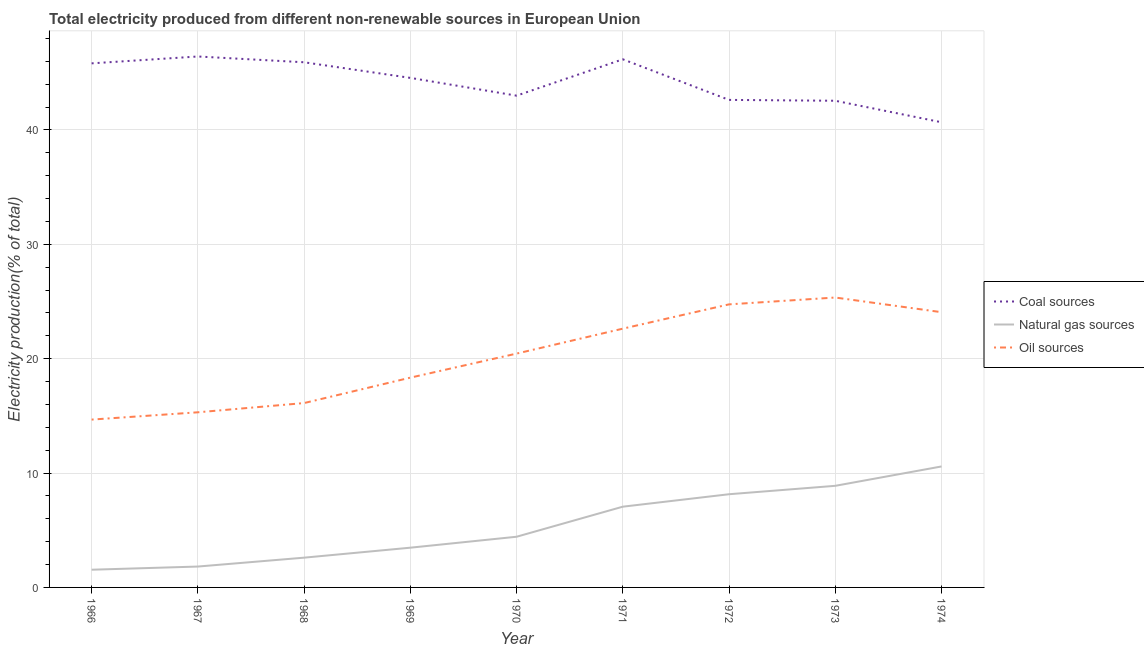What is the percentage of electricity produced by natural gas in 1974?
Offer a very short reply. 10.58. Across all years, what is the maximum percentage of electricity produced by natural gas?
Provide a succinct answer. 10.58. Across all years, what is the minimum percentage of electricity produced by coal?
Give a very brief answer. 40.67. In which year was the percentage of electricity produced by coal maximum?
Give a very brief answer. 1967. In which year was the percentage of electricity produced by natural gas minimum?
Your answer should be compact. 1966. What is the total percentage of electricity produced by coal in the graph?
Offer a terse response. 397.69. What is the difference between the percentage of electricity produced by coal in 1966 and that in 1969?
Offer a terse response. 1.27. What is the difference between the percentage of electricity produced by natural gas in 1974 and the percentage of electricity produced by coal in 1970?
Your answer should be compact. -32.42. What is the average percentage of electricity produced by coal per year?
Provide a succinct answer. 44.19. In the year 1972, what is the difference between the percentage of electricity produced by oil sources and percentage of electricity produced by coal?
Offer a very short reply. -17.87. What is the ratio of the percentage of electricity produced by coal in 1970 to that in 1974?
Give a very brief answer. 1.06. Is the percentage of electricity produced by oil sources in 1967 less than that in 1974?
Your response must be concise. Yes. Is the difference between the percentage of electricity produced by oil sources in 1967 and 1972 greater than the difference between the percentage of electricity produced by coal in 1967 and 1972?
Provide a short and direct response. No. What is the difference between the highest and the second highest percentage of electricity produced by oil sources?
Make the answer very short. 0.6. What is the difference between the highest and the lowest percentage of electricity produced by oil sources?
Provide a short and direct response. 10.67. In how many years, is the percentage of electricity produced by coal greater than the average percentage of electricity produced by coal taken over all years?
Your answer should be compact. 5. Is the sum of the percentage of electricity produced by oil sources in 1972 and 1974 greater than the maximum percentage of electricity produced by coal across all years?
Your answer should be very brief. Yes. Is the percentage of electricity produced by coal strictly greater than the percentage of electricity produced by natural gas over the years?
Offer a very short reply. Yes. What is the difference between two consecutive major ticks on the Y-axis?
Offer a terse response. 10. Are the values on the major ticks of Y-axis written in scientific E-notation?
Give a very brief answer. No. How many legend labels are there?
Keep it short and to the point. 3. How are the legend labels stacked?
Provide a short and direct response. Vertical. What is the title of the graph?
Offer a very short reply. Total electricity produced from different non-renewable sources in European Union. Does "Ages 0-14" appear as one of the legend labels in the graph?
Make the answer very short. No. What is the label or title of the Y-axis?
Give a very brief answer. Electricity production(% of total). What is the Electricity production(% of total) in Coal sources in 1966?
Your answer should be compact. 45.82. What is the Electricity production(% of total) in Natural gas sources in 1966?
Provide a short and direct response. 1.55. What is the Electricity production(% of total) of Oil sources in 1966?
Offer a terse response. 14.67. What is the Electricity production(% of total) in Coal sources in 1967?
Your answer should be very brief. 46.42. What is the Electricity production(% of total) of Natural gas sources in 1967?
Provide a succinct answer. 1.83. What is the Electricity production(% of total) of Oil sources in 1967?
Offer a very short reply. 15.31. What is the Electricity production(% of total) in Coal sources in 1968?
Make the answer very short. 45.91. What is the Electricity production(% of total) of Natural gas sources in 1968?
Your response must be concise. 2.6. What is the Electricity production(% of total) in Oil sources in 1968?
Ensure brevity in your answer.  16.12. What is the Electricity production(% of total) of Coal sources in 1969?
Provide a short and direct response. 44.55. What is the Electricity production(% of total) of Natural gas sources in 1969?
Give a very brief answer. 3.47. What is the Electricity production(% of total) of Oil sources in 1969?
Provide a succinct answer. 18.34. What is the Electricity production(% of total) in Coal sources in 1970?
Your answer should be very brief. 42.99. What is the Electricity production(% of total) in Natural gas sources in 1970?
Offer a very short reply. 4.43. What is the Electricity production(% of total) in Oil sources in 1970?
Your response must be concise. 20.44. What is the Electricity production(% of total) in Coal sources in 1971?
Ensure brevity in your answer.  46.17. What is the Electricity production(% of total) of Natural gas sources in 1971?
Your answer should be very brief. 7.06. What is the Electricity production(% of total) in Oil sources in 1971?
Your answer should be very brief. 22.62. What is the Electricity production(% of total) of Coal sources in 1972?
Give a very brief answer. 42.62. What is the Electricity production(% of total) in Natural gas sources in 1972?
Provide a succinct answer. 8.15. What is the Electricity production(% of total) of Oil sources in 1972?
Offer a terse response. 24.75. What is the Electricity production(% of total) of Coal sources in 1973?
Your answer should be compact. 42.55. What is the Electricity production(% of total) in Natural gas sources in 1973?
Provide a short and direct response. 8.88. What is the Electricity production(% of total) in Oil sources in 1973?
Provide a short and direct response. 25.34. What is the Electricity production(% of total) of Coal sources in 1974?
Your response must be concise. 40.67. What is the Electricity production(% of total) in Natural gas sources in 1974?
Offer a very short reply. 10.58. What is the Electricity production(% of total) of Oil sources in 1974?
Provide a short and direct response. 24.06. Across all years, what is the maximum Electricity production(% of total) in Coal sources?
Offer a terse response. 46.42. Across all years, what is the maximum Electricity production(% of total) of Natural gas sources?
Give a very brief answer. 10.58. Across all years, what is the maximum Electricity production(% of total) in Oil sources?
Your response must be concise. 25.34. Across all years, what is the minimum Electricity production(% of total) of Coal sources?
Provide a succinct answer. 40.67. Across all years, what is the minimum Electricity production(% of total) in Natural gas sources?
Keep it short and to the point. 1.55. Across all years, what is the minimum Electricity production(% of total) of Oil sources?
Offer a very short reply. 14.67. What is the total Electricity production(% of total) in Coal sources in the graph?
Offer a very short reply. 397.69. What is the total Electricity production(% of total) of Natural gas sources in the graph?
Provide a short and direct response. 48.55. What is the total Electricity production(% of total) in Oil sources in the graph?
Give a very brief answer. 181.66. What is the difference between the Electricity production(% of total) of Coal sources in 1966 and that in 1967?
Ensure brevity in your answer.  -0.6. What is the difference between the Electricity production(% of total) of Natural gas sources in 1966 and that in 1967?
Ensure brevity in your answer.  -0.28. What is the difference between the Electricity production(% of total) of Oil sources in 1966 and that in 1967?
Your answer should be very brief. -0.64. What is the difference between the Electricity production(% of total) in Coal sources in 1966 and that in 1968?
Provide a succinct answer. -0.09. What is the difference between the Electricity production(% of total) in Natural gas sources in 1966 and that in 1968?
Give a very brief answer. -1.05. What is the difference between the Electricity production(% of total) in Oil sources in 1966 and that in 1968?
Give a very brief answer. -1.44. What is the difference between the Electricity production(% of total) of Coal sources in 1966 and that in 1969?
Your answer should be very brief. 1.27. What is the difference between the Electricity production(% of total) in Natural gas sources in 1966 and that in 1969?
Your answer should be very brief. -1.93. What is the difference between the Electricity production(% of total) in Oil sources in 1966 and that in 1969?
Make the answer very short. -3.67. What is the difference between the Electricity production(% of total) in Coal sources in 1966 and that in 1970?
Your answer should be very brief. 2.82. What is the difference between the Electricity production(% of total) of Natural gas sources in 1966 and that in 1970?
Keep it short and to the point. -2.88. What is the difference between the Electricity production(% of total) in Oil sources in 1966 and that in 1970?
Offer a very short reply. -5.77. What is the difference between the Electricity production(% of total) of Coal sources in 1966 and that in 1971?
Provide a succinct answer. -0.35. What is the difference between the Electricity production(% of total) of Natural gas sources in 1966 and that in 1971?
Offer a very short reply. -5.51. What is the difference between the Electricity production(% of total) of Oil sources in 1966 and that in 1971?
Offer a terse response. -7.95. What is the difference between the Electricity production(% of total) of Coal sources in 1966 and that in 1972?
Ensure brevity in your answer.  3.2. What is the difference between the Electricity production(% of total) of Natural gas sources in 1966 and that in 1972?
Offer a terse response. -6.6. What is the difference between the Electricity production(% of total) of Oil sources in 1966 and that in 1972?
Provide a short and direct response. -10.07. What is the difference between the Electricity production(% of total) of Coal sources in 1966 and that in 1973?
Your answer should be very brief. 3.27. What is the difference between the Electricity production(% of total) of Natural gas sources in 1966 and that in 1973?
Make the answer very short. -7.33. What is the difference between the Electricity production(% of total) of Oil sources in 1966 and that in 1973?
Provide a succinct answer. -10.67. What is the difference between the Electricity production(% of total) of Coal sources in 1966 and that in 1974?
Ensure brevity in your answer.  5.15. What is the difference between the Electricity production(% of total) in Natural gas sources in 1966 and that in 1974?
Make the answer very short. -9.03. What is the difference between the Electricity production(% of total) in Oil sources in 1966 and that in 1974?
Your response must be concise. -9.39. What is the difference between the Electricity production(% of total) of Coal sources in 1967 and that in 1968?
Offer a very short reply. 0.51. What is the difference between the Electricity production(% of total) in Natural gas sources in 1967 and that in 1968?
Your response must be concise. -0.78. What is the difference between the Electricity production(% of total) in Oil sources in 1967 and that in 1968?
Provide a short and direct response. -0.81. What is the difference between the Electricity production(% of total) in Coal sources in 1967 and that in 1969?
Make the answer very short. 1.87. What is the difference between the Electricity production(% of total) of Natural gas sources in 1967 and that in 1969?
Your answer should be very brief. -1.65. What is the difference between the Electricity production(% of total) in Oil sources in 1967 and that in 1969?
Offer a terse response. -3.03. What is the difference between the Electricity production(% of total) in Coal sources in 1967 and that in 1970?
Provide a short and direct response. 3.42. What is the difference between the Electricity production(% of total) of Natural gas sources in 1967 and that in 1970?
Your answer should be compact. -2.61. What is the difference between the Electricity production(% of total) in Oil sources in 1967 and that in 1970?
Offer a very short reply. -5.13. What is the difference between the Electricity production(% of total) in Coal sources in 1967 and that in 1971?
Your answer should be very brief. 0.25. What is the difference between the Electricity production(% of total) of Natural gas sources in 1967 and that in 1971?
Your answer should be compact. -5.23. What is the difference between the Electricity production(% of total) in Oil sources in 1967 and that in 1971?
Keep it short and to the point. -7.31. What is the difference between the Electricity production(% of total) of Coal sources in 1967 and that in 1972?
Give a very brief answer. 3.8. What is the difference between the Electricity production(% of total) of Natural gas sources in 1967 and that in 1972?
Your response must be concise. -6.32. What is the difference between the Electricity production(% of total) of Oil sources in 1967 and that in 1972?
Keep it short and to the point. -9.44. What is the difference between the Electricity production(% of total) of Coal sources in 1967 and that in 1973?
Your answer should be very brief. 3.87. What is the difference between the Electricity production(% of total) of Natural gas sources in 1967 and that in 1973?
Ensure brevity in your answer.  -7.06. What is the difference between the Electricity production(% of total) in Oil sources in 1967 and that in 1973?
Your answer should be compact. -10.03. What is the difference between the Electricity production(% of total) of Coal sources in 1967 and that in 1974?
Give a very brief answer. 5.75. What is the difference between the Electricity production(% of total) of Natural gas sources in 1967 and that in 1974?
Keep it short and to the point. -8.75. What is the difference between the Electricity production(% of total) in Oil sources in 1967 and that in 1974?
Provide a succinct answer. -8.75. What is the difference between the Electricity production(% of total) in Coal sources in 1968 and that in 1969?
Make the answer very short. 1.36. What is the difference between the Electricity production(% of total) of Natural gas sources in 1968 and that in 1969?
Provide a short and direct response. -0.87. What is the difference between the Electricity production(% of total) of Oil sources in 1968 and that in 1969?
Your response must be concise. -2.22. What is the difference between the Electricity production(% of total) in Coal sources in 1968 and that in 1970?
Keep it short and to the point. 2.92. What is the difference between the Electricity production(% of total) in Natural gas sources in 1968 and that in 1970?
Ensure brevity in your answer.  -1.83. What is the difference between the Electricity production(% of total) in Oil sources in 1968 and that in 1970?
Keep it short and to the point. -4.32. What is the difference between the Electricity production(% of total) in Coal sources in 1968 and that in 1971?
Offer a terse response. -0.26. What is the difference between the Electricity production(% of total) of Natural gas sources in 1968 and that in 1971?
Provide a succinct answer. -4.46. What is the difference between the Electricity production(% of total) in Oil sources in 1968 and that in 1971?
Provide a succinct answer. -6.5. What is the difference between the Electricity production(% of total) in Coal sources in 1968 and that in 1972?
Provide a succinct answer. 3.29. What is the difference between the Electricity production(% of total) of Natural gas sources in 1968 and that in 1972?
Keep it short and to the point. -5.55. What is the difference between the Electricity production(% of total) in Oil sources in 1968 and that in 1972?
Offer a terse response. -8.63. What is the difference between the Electricity production(% of total) of Coal sources in 1968 and that in 1973?
Offer a terse response. 3.36. What is the difference between the Electricity production(% of total) of Natural gas sources in 1968 and that in 1973?
Make the answer very short. -6.28. What is the difference between the Electricity production(% of total) in Oil sources in 1968 and that in 1973?
Your answer should be compact. -9.23. What is the difference between the Electricity production(% of total) in Coal sources in 1968 and that in 1974?
Offer a very short reply. 5.24. What is the difference between the Electricity production(% of total) in Natural gas sources in 1968 and that in 1974?
Make the answer very short. -7.97. What is the difference between the Electricity production(% of total) in Oil sources in 1968 and that in 1974?
Your response must be concise. -7.94. What is the difference between the Electricity production(% of total) of Coal sources in 1969 and that in 1970?
Keep it short and to the point. 1.55. What is the difference between the Electricity production(% of total) in Natural gas sources in 1969 and that in 1970?
Give a very brief answer. -0.96. What is the difference between the Electricity production(% of total) in Oil sources in 1969 and that in 1970?
Make the answer very short. -2.1. What is the difference between the Electricity production(% of total) in Coal sources in 1969 and that in 1971?
Your answer should be very brief. -1.62. What is the difference between the Electricity production(% of total) of Natural gas sources in 1969 and that in 1971?
Provide a succinct answer. -3.58. What is the difference between the Electricity production(% of total) in Oil sources in 1969 and that in 1971?
Ensure brevity in your answer.  -4.28. What is the difference between the Electricity production(% of total) of Coal sources in 1969 and that in 1972?
Ensure brevity in your answer.  1.93. What is the difference between the Electricity production(% of total) of Natural gas sources in 1969 and that in 1972?
Ensure brevity in your answer.  -4.67. What is the difference between the Electricity production(% of total) in Oil sources in 1969 and that in 1972?
Your answer should be compact. -6.41. What is the difference between the Electricity production(% of total) in Coal sources in 1969 and that in 1973?
Your response must be concise. 2. What is the difference between the Electricity production(% of total) of Natural gas sources in 1969 and that in 1973?
Your response must be concise. -5.41. What is the difference between the Electricity production(% of total) of Oil sources in 1969 and that in 1973?
Your response must be concise. -7. What is the difference between the Electricity production(% of total) in Coal sources in 1969 and that in 1974?
Your answer should be compact. 3.88. What is the difference between the Electricity production(% of total) in Natural gas sources in 1969 and that in 1974?
Provide a short and direct response. -7.1. What is the difference between the Electricity production(% of total) in Oil sources in 1969 and that in 1974?
Give a very brief answer. -5.72. What is the difference between the Electricity production(% of total) in Coal sources in 1970 and that in 1971?
Provide a succinct answer. -3.18. What is the difference between the Electricity production(% of total) in Natural gas sources in 1970 and that in 1971?
Your answer should be very brief. -2.63. What is the difference between the Electricity production(% of total) in Oil sources in 1970 and that in 1971?
Your response must be concise. -2.18. What is the difference between the Electricity production(% of total) in Coal sources in 1970 and that in 1972?
Keep it short and to the point. 0.37. What is the difference between the Electricity production(% of total) of Natural gas sources in 1970 and that in 1972?
Your answer should be compact. -3.72. What is the difference between the Electricity production(% of total) of Oil sources in 1970 and that in 1972?
Your response must be concise. -4.3. What is the difference between the Electricity production(% of total) in Coal sources in 1970 and that in 1973?
Keep it short and to the point. 0.45. What is the difference between the Electricity production(% of total) of Natural gas sources in 1970 and that in 1973?
Offer a very short reply. -4.45. What is the difference between the Electricity production(% of total) in Oil sources in 1970 and that in 1973?
Offer a terse response. -4.9. What is the difference between the Electricity production(% of total) of Coal sources in 1970 and that in 1974?
Your answer should be compact. 2.33. What is the difference between the Electricity production(% of total) of Natural gas sources in 1970 and that in 1974?
Provide a succinct answer. -6.14. What is the difference between the Electricity production(% of total) in Oil sources in 1970 and that in 1974?
Your answer should be very brief. -3.62. What is the difference between the Electricity production(% of total) of Coal sources in 1971 and that in 1972?
Your answer should be compact. 3.55. What is the difference between the Electricity production(% of total) of Natural gas sources in 1971 and that in 1972?
Offer a terse response. -1.09. What is the difference between the Electricity production(% of total) in Oil sources in 1971 and that in 1972?
Make the answer very short. -2.12. What is the difference between the Electricity production(% of total) in Coal sources in 1971 and that in 1973?
Your response must be concise. 3.62. What is the difference between the Electricity production(% of total) in Natural gas sources in 1971 and that in 1973?
Offer a very short reply. -1.82. What is the difference between the Electricity production(% of total) in Oil sources in 1971 and that in 1973?
Offer a very short reply. -2.72. What is the difference between the Electricity production(% of total) of Coal sources in 1971 and that in 1974?
Ensure brevity in your answer.  5.5. What is the difference between the Electricity production(% of total) in Natural gas sources in 1971 and that in 1974?
Give a very brief answer. -3.52. What is the difference between the Electricity production(% of total) of Oil sources in 1971 and that in 1974?
Give a very brief answer. -1.44. What is the difference between the Electricity production(% of total) of Coal sources in 1972 and that in 1973?
Give a very brief answer. 0.07. What is the difference between the Electricity production(% of total) of Natural gas sources in 1972 and that in 1973?
Ensure brevity in your answer.  -0.73. What is the difference between the Electricity production(% of total) in Oil sources in 1972 and that in 1973?
Offer a very short reply. -0.6. What is the difference between the Electricity production(% of total) of Coal sources in 1972 and that in 1974?
Your answer should be very brief. 1.95. What is the difference between the Electricity production(% of total) in Natural gas sources in 1972 and that in 1974?
Give a very brief answer. -2.43. What is the difference between the Electricity production(% of total) of Oil sources in 1972 and that in 1974?
Your response must be concise. 0.68. What is the difference between the Electricity production(% of total) in Coal sources in 1973 and that in 1974?
Keep it short and to the point. 1.88. What is the difference between the Electricity production(% of total) of Natural gas sources in 1973 and that in 1974?
Your answer should be compact. -1.69. What is the difference between the Electricity production(% of total) in Oil sources in 1973 and that in 1974?
Provide a short and direct response. 1.28. What is the difference between the Electricity production(% of total) in Coal sources in 1966 and the Electricity production(% of total) in Natural gas sources in 1967?
Your response must be concise. 43.99. What is the difference between the Electricity production(% of total) of Coal sources in 1966 and the Electricity production(% of total) of Oil sources in 1967?
Provide a succinct answer. 30.51. What is the difference between the Electricity production(% of total) in Natural gas sources in 1966 and the Electricity production(% of total) in Oil sources in 1967?
Your answer should be very brief. -13.76. What is the difference between the Electricity production(% of total) in Coal sources in 1966 and the Electricity production(% of total) in Natural gas sources in 1968?
Make the answer very short. 43.21. What is the difference between the Electricity production(% of total) of Coal sources in 1966 and the Electricity production(% of total) of Oil sources in 1968?
Ensure brevity in your answer.  29.7. What is the difference between the Electricity production(% of total) of Natural gas sources in 1966 and the Electricity production(% of total) of Oil sources in 1968?
Give a very brief answer. -14.57. What is the difference between the Electricity production(% of total) in Coal sources in 1966 and the Electricity production(% of total) in Natural gas sources in 1969?
Your answer should be very brief. 42.34. What is the difference between the Electricity production(% of total) in Coal sources in 1966 and the Electricity production(% of total) in Oil sources in 1969?
Keep it short and to the point. 27.48. What is the difference between the Electricity production(% of total) of Natural gas sources in 1966 and the Electricity production(% of total) of Oil sources in 1969?
Your answer should be compact. -16.79. What is the difference between the Electricity production(% of total) in Coal sources in 1966 and the Electricity production(% of total) in Natural gas sources in 1970?
Offer a very short reply. 41.39. What is the difference between the Electricity production(% of total) of Coal sources in 1966 and the Electricity production(% of total) of Oil sources in 1970?
Provide a short and direct response. 25.37. What is the difference between the Electricity production(% of total) of Natural gas sources in 1966 and the Electricity production(% of total) of Oil sources in 1970?
Make the answer very short. -18.89. What is the difference between the Electricity production(% of total) of Coal sources in 1966 and the Electricity production(% of total) of Natural gas sources in 1971?
Ensure brevity in your answer.  38.76. What is the difference between the Electricity production(% of total) in Coal sources in 1966 and the Electricity production(% of total) in Oil sources in 1971?
Provide a short and direct response. 23.19. What is the difference between the Electricity production(% of total) in Natural gas sources in 1966 and the Electricity production(% of total) in Oil sources in 1971?
Give a very brief answer. -21.07. What is the difference between the Electricity production(% of total) in Coal sources in 1966 and the Electricity production(% of total) in Natural gas sources in 1972?
Provide a short and direct response. 37.67. What is the difference between the Electricity production(% of total) of Coal sources in 1966 and the Electricity production(% of total) of Oil sources in 1972?
Provide a short and direct response. 21.07. What is the difference between the Electricity production(% of total) in Natural gas sources in 1966 and the Electricity production(% of total) in Oil sources in 1972?
Offer a terse response. -23.2. What is the difference between the Electricity production(% of total) of Coal sources in 1966 and the Electricity production(% of total) of Natural gas sources in 1973?
Provide a succinct answer. 36.93. What is the difference between the Electricity production(% of total) of Coal sources in 1966 and the Electricity production(% of total) of Oil sources in 1973?
Provide a succinct answer. 20.47. What is the difference between the Electricity production(% of total) of Natural gas sources in 1966 and the Electricity production(% of total) of Oil sources in 1973?
Your response must be concise. -23.8. What is the difference between the Electricity production(% of total) in Coal sources in 1966 and the Electricity production(% of total) in Natural gas sources in 1974?
Your response must be concise. 35.24. What is the difference between the Electricity production(% of total) in Coal sources in 1966 and the Electricity production(% of total) in Oil sources in 1974?
Your answer should be compact. 21.75. What is the difference between the Electricity production(% of total) of Natural gas sources in 1966 and the Electricity production(% of total) of Oil sources in 1974?
Offer a terse response. -22.51. What is the difference between the Electricity production(% of total) in Coal sources in 1967 and the Electricity production(% of total) in Natural gas sources in 1968?
Your response must be concise. 43.81. What is the difference between the Electricity production(% of total) in Coal sources in 1967 and the Electricity production(% of total) in Oil sources in 1968?
Give a very brief answer. 30.3. What is the difference between the Electricity production(% of total) of Natural gas sources in 1967 and the Electricity production(% of total) of Oil sources in 1968?
Your answer should be compact. -14.29. What is the difference between the Electricity production(% of total) of Coal sources in 1967 and the Electricity production(% of total) of Natural gas sources in 1969?
Provide a short and direct response. 42.94. What is the difference between the Electricity production(% of total) of Coal sources in 1967 and the Electricity production(% of total) of Oil sources in 1969?
Make the answer very short. 28.08. What is the difference between the Electricity production(% of total) of Natural gas sources in 1967 and the Electricity production(% of total) of Oil sources in 1969?
Keep it short and to the point. -16.51. What is the difference between the Electricity production(% of total) in Coal sources in 1967 and the Electricity production(% of total) in Natural gas sources in 1970?
Offer a very short reply. 41.99. What is the difference between the Electricity production(% of total) of Coal sources in 1967 and the Electricity production(% of total) of Oil sources in 1970?
Your response must be concise. 25.97. What is the difference between the Electricity production(% of total) in Natural gas sources in 1967 and the Electricity production(% of total) in Oil sources in 1970?
Make the answer very short. -18.62. What is the difference between the Electricity production(% of total) in Coal sources in 1967 and the Electricity production(% of total) in Natural gas sources in 1971?
Ensure brevity in your answer.  39.36. What is the difference between the Electricity production(% of total) in Coal sources in 1967 and the Electricity production(% of total) in Oil sources in 1971?
Your answer should be compact. 23.79. What is the difference between the Electricity production(% of total) in Natural gas sources in 1967 and the Electricity production(% of total) in Oil sources in 1971?
Your answer should be compact. -20.8. What is the difference between the Electricity production(% of total) in Coal sources in 1967 and the Electricity production(% of total) in Natural gas sources in 1972?
Ensure brevity in your answer.  38.27. What is the difference between the Electricity production(% of total) in Coal sources in 1967 and the Electricity production(% of total) in Oil sources in 1972?
Give a very brief answer. 21.67. What is the difference between the Electricity production(% of total) in Natural gas sources in 1967 and the Electricity production(% of total) in Oil sources in 1972?
Your answer should be very brief. -22.92. What is the difference between the Electricity production(% of total) of Coal sources in 1967 and the Electricity production(% of total) of Natural gas sources in 1973?
Ensure brevity in your answer.  37.53. What is the difference between the Electricity production(% of total) in Coal sources in 1967 and the Electricity production(% of total) in Oil sources in 1973?
Offer a terse response. 21.07. What is the difference between the Electricity production(% of total) in Natural gas sources in 1967 and the Electricity production(% of total) in Oil sources in 1973?
Make the answer very short. -23.52. What is the difference between the Electricity production(% of total) in Coal sources in 1967 and the Electricity production(% of total) in Natural gas sources in 1974?
Provide a short and direct response. 35.84. What is the difference between the Electricity production(% of total) of Coal sources in 1967 and the Electricity production(% of total) of Oil sources in 1974?
Provide a succinct answer. 22.35. What is the difference between the Electricity production(% of total) of Natural gas sources in 1967 and the Electricity production(% of total) of Oil sources in 1974?
Your answer should be compact. -22.24. What is the difference between the Electricity production(% of total) of Coal sources in 1968 and the Electricity production(% of total) of Natural gas sources in 1969?
Offer a terse response. 42.44. What is the difference between the Electricity production(% of total) in Coal sources in 1968 and the Electricity production(% of total) in Oil sources in 1969?
Offer a terse response. 27.57. What is the difference between the Electricity production(% of total) in Natural gas sources in 1968 and the Electricity production(% of total) in Oil sources in 1969?
Your answer should be very brief. -15.74. What is the difference between the Electricity production(% of total) in Coal sources in 1968 and the Electricity production(% of total) in Natural gas sources in 1970?
Your answer should be compact. 41.48. What is the difference between the Electricity production(% of total) of Coal sources in 1968 and the Electricity production(% of total) of Oil sources in 1970?
Your answer should be very brief. 25.47. What is the difference between the Electricity production(% of total) in Natural gas sources in 1968 and the Electricity production(% of total) in Oil sources in 1970?
Ensure brevity in your answer.  -17.84. What is the difference between the Electricity production(% of total) of Coal sources in 1968 and the Electricity production(% of total) of Natural gas sources in 1971?
Keep it short and to the point. 38.85. What is the difference between the Electricity production(% of total) of Coal sources in 1968 and the Electricity production(% of total) of Oil sources in 1971?
Give a very brief answer. 23.29. What is the difference between the Electricity production(% of total) of Natural gas sources in 1968 and the Electricity production(% of total) of Oil sources in 1971?
Offer a terse response. -20.02. What is the difference between the Electricity production(% of total) of Coal sources in 1968 and the Electricity production(% of total) of Natural gas sources in 1972?
Provide a succinct answer. 37.76. What is the difference between the Electricity production(% of total) in Coal sources in 1968 and the Electricity production(% of total) in Oil sources in 1972?
Your answer should be very brief. 21.16. What is the difference between the Electricity production(% of total) of Natural gas sources in 1968 and the Electricity production(% of total) of Oil sources in 1972?
Your answer should be very brief. -22.14. What is the difference between the Electricity production(% of total) of Coal sources in 1968 and the Electricity production(% of total) of Natural gas sources in 1973?
Give a very brief answer. 37.03. What is the difference between the Electricity production(% of total) of Coal sources in 1968 and the Electricity production(% of total) of Oil sources in 1973?
Keep it short and to the point. 20.57. What is the difference between the Electricity production(% of total) of Natural gas sources in 1968 and the Electricity production(% of total) of Oil sources in 1973?
Offer a very short reply. -22.74. What is the difference between the Electricity production(% of total) of Coal sources in 1968 and the Electricity production(% of total) of Natural gas sources in 1974?
Ensure brevity in your answer.  35.34. What is the difference between the Electricity production(% of total) in Coal sources in 1968 and the Electricity production(% of total) in Oil sources in 1974?
Your response must be concise. 21.85. What is the difference between the Electricity production(% of total) of Natural gas sources in 1968 and the Electricity production(% of total) of Oil sources in 1974?
Ensure brevity in your answer.  -21.46. What is the difference between the Electricity production(% of total) in Coal sources in 1969 and the Electricity production(% of total) in Natural gas sources in 1970?
Your answer should be compact. 40.12. What is the difference between the Electricity production(% of total) in Coal sources in 1969 and the Electricity production(% of total) in Oil sources in 1970?
Your response must be concise. 24.1. What is the difference between the Electricity production(% of total) in Natural gas sources in 1969 and the Electricity production(% of total) in Oil sources in 1970?
Offer a very short reply. -16.97. What is the difference between the Electricity production(% of total) of Coal sources in 1969 and the Electricity production(% of total) of Natural gas sources in 1971?
Provide a short and direct response. 37.49. What is the difference between the Electricity production(% of total) of Coal sources in 1969 and the Electricity production(% of total) of Oil sources in 1971?
Your response must be concise. 21.92. What is the difference between the Electricity production(% of total) in Natural gas sources in 1969 and the Electricity production(% of total) in Oil sources in 1971?
Give a very brief answer. -19.15. What is the difference between the Electricity production(% of total) in Coal sources in 1969 and the Electricity production(% of total) in Natural gas sources in 1972?
Make the answer very short. 36.4. What is the difference between the Electricity production(% of total) in Coal sources in 1969 and the Electricity production(% of total) in Oil sources in 1972?
Offer a terse response. 19.8. What is the difference between the Electricity production(% of total) of Natural gas sources in 1969 and the Electricity production(% of total) of Oil sources in 1972?
Offer a terse response. -21.27. What is the difference between the Electricity production(% of total) of Coal sources in 1969 and the Electricity production(% of total) of Natural gas sources in 1973?
Ensure brevity in your answer.  35.66. What is the difference between the Electricity production(% of total) of Coal sources in 1969 and the Electricity production(% of total) of Oil sources in 1973?
Offer a very short reply. 19.2. What is the difference between the Electricity production(% of total) of Natural gas sources in 1969 and the Electricity production(% of total) of Oil sources in 1973?
Your answer should be very brief. -21.87. What is the difference between the Electricity production(% of total) in Coal sources in 1969 and the Electricity production(% of total) in Natural gas sources in 1974?
Offer a very short reply. 33.97. What is the difference between the Electricity production(% of total) of Coal sources in 1969 and the Electricity production(% of total) of Oil sources in 1974?
Give a very brief answer. 20.48. What is the difference between the Electricity production(% of total) of Natural gas sources in 1969 and the Electricity production(% of total) of Oil sources in 1974?
Provide a succinct answer. -20.59. What is the difference between the Electricity production(% of total) in Coal sources in 1970 and the Electricity production(% of total) in Natural gas sources in 1971?
Offer a terse response. 35.93. What is the difference between the Electricity production(% of total) in Coal sources in 1970 and the Electricity production(% of total) in Oil sources in 1971?
Keep it short and to the point. 20.37. What is the difference between the Electricity production(% of total) of Natural gas sources in 1970 and the Electricity production(% of total) of Oil sources in 1971?
Provide a short and direct response. -18.19. What is the difference between the Electricity production(% of total) of Coal sources in 1970 and the Electricity production(% of total) of Natural gas sources in 1972?
Make the answer very short. 34.84. What is the difference between the Electricity production(% of total) of Coal sources in 1970 and the Electricity production(% of total) of Oil sources in 1972?
Provide a succinct answer. 18.25. What is the difference between the Electricity production(% of total) in Natural gas sources in 1970 and the Electricity production(% of total) in Oil sources in 1972?
Provide a short and direct response. -20.32. What is the difference between the Electricity production(% of total) of Coal sources in 1970 and the Electricity production(% of total) of Natural gas sources in 1973?
Provide a short and direct response. 34.11. What is the difference between the Electricity production(% of total) of Coal sources in 1970 and the Electricity production(% of total) of Oil sources in 1973?
Offer a very short reply. 17.65. What is the difference between the Electricity production(% of total) of Natural gas sources in 1970 and the Electricity production(% of total) of Oil sources in 1973?
Provide a succinct answer. -20.91. What is the difference between the Electricity production(% of total) in Coal sources in 1970 and the Electricity production(% of total) in Natural gas sources in 1974?
Make the answer very short. 32.42. What is the difference between the Electricity production(% of total) in Coal sources in 1970 and the Electricity production(% of total) in Oil sources in 1974?
Keep it short and to the point. 18.93. What is the difference between the Electricity production(% of total) in Natural gas sources in 1970 and the Electricity production(% of total) in Oil sources in 1974?
Provide a short and direct response. -19.63. What is the difference between the Electricity production(% of total) of Coal sources in 1971 and the Electricity production(% of total) of Natural gas sources in 1972?
Your response must be concise. 38.02. What is the difference between the Electricity production(% of total) in Coal sources in 1971 and the Electricity production(% of total) in Oil sources in 1972?
Your answer should be compact. 21.42. What is the difference between the Electricity production(% of total) of Natural gas sources in 1971 and the Electricity production(% of total) of Oil sources in 1972?
Provide a succinct answer. -17.69. What is the difference between the Electricity production(% of total) of Coal sources in 1971 and the Electricity production(% of total) of Natural gas sources in 1973?
Provide a succinct answer. 37.29. What is the difference between the Electricity production(% of total) of Coal sources in 1971 and the Electricity production(% of total) of Oil sources in 1973?
Your answer should be compact. 20.83. What is the difference between the Electricity production(% of total) of Natural gas sources in 1971 and the Electricity production(% of total) of Oil sources in 1973?
Provide a short and direct response. -18.29. What is the difference between the Electricity production(% of total) of Coal sources in 1971 and the Electricity production(% of total) of Natural gas sources in 1974?
Ensure brevity in your answer.  35.6. What is the difference between the Electricity production(% of total) in Coal sources in 1971 and the Electricity production(% of total) in Oil sources in 1974?
Provide a succinct answer. 22.11. What is the difference between the Electricity production(% of total) of Natural gas sources in 1971 and the Electricity production(% of total) of Oil sources in 1974?
Give a very brief answer. -17. What is the difference between the Electricity production(% of total) of Coal sources in 1972 and the Electricity production(% of total) of Natural gas sources in 1973?
Give a very brief answer. 33.74. What is the difference between the Electricity production(% of total) in Coal sources in 1972 and the Electricity production(% of total) in Oil sources in 1973?
Keep it short and to the point. 17.28. What is the difference between the Electricity production(% of total) in Natural gas sources in 1972 and the Electricity production(% of total) in Oil sources in 1973?
Make the answer very short. -17.2. What is the difference between the Electricity production(% of total) in Coal sources in 1972 and the Electricity production(% of total) in Natural gas sources in 1974?
Give a very brief answer. 32.05. What is the difference between the Electricity production(% of total) of Coal sources in 1972 and the Electricity production(% of total) of Oil sources in 1974?
Ensure brevity in your answer.  18.56. What is the difference between the Electricity production(% of total) of Natural gas sources in 1972 and the Electricity production(% of total) of Oil sources in 1974?
Provide a short and direct response. -15.91. What is the difference between the Electricity production(% of total) of Coal sources in 1973 and the Electricity production(% of total) of Natural gas sources in 1974?
Your answer should be very brief. 31.97. What is the difference between the Electricity production(% of total) in Coal sources in 1973 and the Electricity production(% of total) in Oil sources in 1974?
Keep it short and to the point. 18.48. What is the difference between the Electricity production(% of total) in Natural gas sources in 1973 and the Electricity production(% of total) in Oil sources in 1974?
Offer a terse response. -15.18. What is the average Electricity production(% of total) in Coal sources per year?
Give a very brief answer. 44.19. What is the average Electricity production(% of total) in Natural gas sources per year?
Give a very brief answer. 5.39. What is the average Electricity production(% of total) of Oil sources per year?
Offer a terse response. 20.18. In the year 1966, what is the difference between the Electricity production(% of total) in Coal sources and Electricity production(% of total) in Natural gas sources?
Your answer should be very brief. 44.27. In the year 1966, what is the difference between the Electricity production(% of total) of Coal sources and Electricity production(% of total) of Oil sources?
Provide a succinct answer. 31.14. In the year 1966, what is the difference between the Electricity production(% of total) of Natural gas sources and Electricity production(% of total) of Oil sources?
Provide a short and direct response. -13.12. In the year 1967, what is the difference between the Electricity production(% of total) of Coal sources and Electricity production(% of total) of Natural gas sources?
Your response must be concise. 44.59. In the year 1967, what is the difference between the Electricity production(% of total) of Coal sources and Electricity production(% of total) of Oil sources?
Offer a terse response. 31.11. In the year 1967, what is the difference between the Electricity production(% of total) in Natural gas sources and Electricity production(% of total) in Oil sources?
Your answer should be very brief. -13.49. In the year 1968, what is the difference between the Electricity production(% of total) in Coal sources and Electricity production(% of total) in Natural gas sources?
Provide a short and direct response. 43.31. In the year 1968, what is the difference between the Electricity production(% of total) of Coal sources and Electricity production(% of total) of Oil sources?
Keep it short and to the point. 29.79. In the year 1968, what is the difference between the Electricity production(% of total) in Natural gas sources and Electricity production(% of total) in Oil sources?
Provide a succinct answer. -13.52. In the year 1969, what is the difference between the Electricity production(% of total) in Coal sources and Electricity production(% of total) in Natural gas sources?
Provide a succinct answer. 41.07. In the year 1969, what is the difference between the Electricity production(% of total) in Coal sources and Electricity production(% of total) in Oil sources?
Provide a short and direct response. 26.21. In the year 1969, what is the difference between the Electricity production(% of total) of Natural gas sources and Electricity production(% of total) of Oil sources?
Ensure brevity in your answer.  -14.87. In the year 1970, what is the difference between the Electricity production(% of total) of Coal sources and Electricity production(% of total) of Natural gas sources?
Your answer should be compact. 38.56. In the year 1970, what is the difference between the Electricity production(% of total) of Coal sources and Electricity production(% of total) of Oil sources?
Provide a short and direct response. 22.55. In the year 1970, what is the difference between the Electricity production(% of total) of Natural gas sources and Electricity production(% of total) of Oil sources?
Your answer should be compact. -16.01. In the year 1971, what is the difference between the Electricity production(% of total) of Coal sources and Electricity production(% of total) of Natural gas sources?
Keep it short and to the point. 39.11. In the year 1971, what is the difference between the Electricity production(% of total) of Coal sources and Electricity production(% of total) of Oil sources?
Make the answer very short. 23.55. In the year 1971, what is the difference between the Electricity production(% of total) of Natural gas sources and Electricity production(% of total) of Oil sources?
Offer a very short reply. -15.56. In the year 1972, what is the difference between the Electricity production(% of total) in Coal sources and Electricity production(% of total) in Natural gas sources?
Give a very brief answer. 34.47. In the year 1972, what is the difference between the Electricity production(% of total) of Coal sources and Electricity production(% of total) of Oil sources?
Your answer should be very brief. 17.87. In the year 1972, what is the difference between the Electricity production(% of total) of Natural gas sources and Electricity production(% of total) of Oil sources?
Make the answer very short. -16.6. In the year 1973, what is the difference between the Electricity production(% of total) in Coal sources and Electricity production(% of total) in Natural gas sources?
Offer a terse response. 33.66. In the year 1973, what is the difference between the Electricity production(% of total) of Coal sources and Electricity production(% of total) of Oil sources?
Your answer should be compact. 17.2. In the year 1973, what is the difference between the Electricity production(% of total) in Natural gas sources and Electricity production(% of total) in Oil sources?
Offer a very short reply. -16.46. In the year 1974, what is the difference between the Electricity production(% of total) in Coal sources and Electricity production(% of total) in Natural gas sources?
Offer a terse response. 30.09. In the year 1974, what is the difference between the Electricity production(% of total) of Coal sources and Electricity production(% of total) of Oil sources?
Give a very brief answer. 16.6. In the year 1974, what is the difference between the Electricity production(% of total) in Natural gas sources and Electricity production(% of total) in Oil sources?
Provide a short and direct response. -13.49. What is the ratio of the Electricity production(% of total) of Coal sources in 1966 to that in 1967?
Make the answer very short. 0.99. What is the ratio of the Electricity production(% of total) in Natural gas sources in 1966 to that in 1967?
Offer a terse response. 0.85. What is the ratio of the Electricity production(% of total) of Coal sources in 1966 to that in 1968?
Your answer should be compact. 1. What is the ratio of the Electricity production(% of total) of Natural gas sources in 1966 to that in 1968?
Offer a terse response. 0.59. What is the ratio of the Electricity production(% of total) in Oil sources in 1966 to that in 1968?
Keep it short and to the point. 0.91. What is the ratio of the Electricity production(% of total) of Coal sources in 1966 to that in 1969?
Make the answer very short. 1.03. What is the ratio of the Electricity production(% of total) in Natural gas sources in 1966 to that in 1969?
Provide a short and direct response. 0.45. What is the ratio of the Electricity production(% of total) of Oil sources in 1966 to that in 1969?
Your answer should be compact. 0.8. What is the ratio of the Electricity production(% of total) in Coal sources in 1966 to that in 1970?
Your answer should be very brief. 1.07. What is the ratio of the Electricity production(% of total) of Natural gas sources in 1966 to that in 1970?
Keep it short and to the point. 0.35. What is the ratio of the Electricity production(% of total) of Oil sources in 1966 to that in 1970?
Your response must be concise. 0.72. What is the ratio of the Electricity production(% of total) in Coal sources in 1966 to that in 1971?
Provide a short and direct response. 0.99. What is the ratio of the Electricity production(% of total) in Natural gas sources in 1966 to that in 1971?
Provide a succinct answer. 0.22. What is the ratio of the Electricity production(% of total) of Oil sources in 1966 to that in 1971?
Provide a succinct answer. 0.65. What is the ratio of the Electricity production(% of total) of Coal sources in 1966 to that in 1972?
Provide a succinct answer. 1.07. What is the ratio of the Electricity production(% of total) in Natural gas sources in 1966 to that in 1972?
Make the answer very short. 0.19. What is the ratio of the Electricity production(% of total) of Oil sources in 1966 to that in 1972?
Your response must be concise. 0.59. What is the ratio of the Electricity production(% of total) of Coal sources in 1966 to that in 1973?
Make the answer very short. 1.08. What is the ratio of the Electricity production(% of total) in Natural gas sources in 1966 to that in 1973?
Give a very brief answer. 0.17. What is the ratio of the Electricity production(% of total) of Oil sources in 1966 to that in 1973?
Your answer should be very brief. 0.58. What is the ratio of the Electricity production(% of total) of Coal sources in 1966 to that in 1974?
Your response must be concise. 1.13. What is the ratio of the Electricity production(% of total) of Natural gas sources in 1966 to that in 1974?
Offer a very short reply. 0.15. What is the ratio of the Electricity production(% of total) of Oil sources in 1966 to that in 1974?
Offer a very short reply. 0.61. What is the ratio of the Electricity production(% of total) in Coal sources in 1967 to that in 1968?
Keep it short and to the point. 1.01. What is the ratio of the Electricity production(% of total) in Natural gas sources in 1967 to that in 1968?
Your answer should be very brief. 0.7. What is the ratio of the Electricity production(% of total) in Oil sources in 1967 to that in 1968?
Give a very brief answer. 0.95. What is the ratio of the Electricity production(% of total) of Coal sources in 1967 to that in 1969?
Offer a terse response. 1.04. What is the ratio of the Electricity production(% of total) in Natural gas sources in 1967 to that in 1969?
Your response must be concise. 0.53. What is the ratio of the Electricity production(% of total) of Oil sources in 1967 to that in 1969?
Give a very brief answer. 0.83. What is the ratio of the Electricity production(% of total) in Coal sources in 1967 to that in 1970?
Make the answer very short. 1.08. What is the ratio of the Electricity production(% of total) of Natural gas sources in 1967 to that in 1970?
Ensure brevity in your answer.  0.41. What is the ratio of the Electricity production(% of total) in Oil sources in 1967 to that in 1970?
Make the answer very short. 0.75. What is the ratio of the Electricity production(% of total) of Natural gas sources in 1967 to that in 1971?
Provide a short and direct response. 0.26. What is the ratio of the Electricity production(% of total) in Oil sources in 1967 to that in 1971?
Give a very brief answer. 0.68. What is the ratio of the Electricity production(% of total) of Coal sources in 1967 to that in 1972?
Your answer should be compact. 1.09. What is the ratio of the Electricity production(% of total) of Natural gas sources in 1967 to that in 1972?
Your response must be concise. 0.22. What is the ratio of the Electricity production(% of total) in Oil sources in 1967 to that in 1972?
Provide a succinct answer. 0.62. What is the ratio of the Electricity production(% of total) in Coal sources in 1967 to that in 1973?
Your answer should be compact. 1.09. What is the ratio of the Electricity production(% of total) in Natural gas sources in 1967 to that in 1973?
Ensure brevity in your answer.  0.21. What is the ratio of the Electricity production(% of total) of Oil sources in 1967 to that in 1973?
Your answer should be compact. 0.6. What is the ratio of the Electricity production(% of total) in Coal sources in 1967 to that in 1974?
Offer a very short reply. 1.14. What is the ratio of the Electricity production(% of total) of Natural gas sources in 1967 to that in 1974?
Give a very brief answer. 0.17. What is the ratio of the Electricity production(% of total) of Oil sources in 1967 to that in 1974?
Your answer should be very brief. 0.64. What is the ratio of the Electricity production(% of total) in Coal sources in 1968 to that in 1969?
Your answer should be very brief. 1.03. What is the ratio of the Electricity production(% of total) of Natural gas sources in 1968 to that in 1969?
Provide a succinct answer. 0.75. What is the ratio of the Electricity production(% of total) in Oil sources in 1968 to that in 1969?
Your response must be concise. 0.88. What is the ratio of the Electricity production(% of total) in Coal sources in 1968 to that in 1970?
Your answer should be compact. 1.07. What is the ratio of the Electricity production(% of total) of Natural gas sources in 1968 to that in 1970?
Ensure brevity in your answer.  0.59. What is the ratio of the Electricity production(% of total) in Oil sources in 1968 to that in 1970?
Ensure brevity in your answer.  0.79. What is the ratio of the Electricity production(% of total) in Coal sources in 1968 to that in 1971?
Your answer should be compact. 0.99. What is the ratio of the Electricity production(% of total) in Natural gas sources in 1968 to that in 1971?
Your answer should be very brief. 0.37. What is the ratio of the Electricity production(% of total) of Oil sources in 1968 to that in 1971?
Your answer should be compact. 0.71. What is the ratio of the Electricity production(% of total) in Coal sources in 1968 to that in 1972?
Offer a very short reply. 1.08. What is the ratio of the Electricity production(% of total) of Natural gas sources in 1968 to that in 1972?
Your answer should be very brief. 0.32. What is the ratio of the Electricity production(% of total) in Oil sources in 1968 to that in 1972?
Your response must be concise. 0.65. What is the ratio of the Electricity production(% of total) in Coal sources in 1968 to that in 1973?
Provide a succinct answer. 1.08. What is the ratio of the Electricity production(% of total) of Natural gas sources in 1968 to that in 1973?
Your answer should be compact. 0.29. What is the ratio of the Electricity production(% of total) of Oil sources in 1968 to that in 1973?
Provide a succinct answer. 0.64. What is the ratio of the Electricity production(% of total) of Coal sources in 1968 to that in 1974?
Keep it short and to the point. 1.13. What is the ratio of the Electricity production(% of total) of Natural gas sources in 1968 to that in 1974?
Make the answer very short. 0.25. What is the ratio of the Electricity production(% of total) of Oil sources in 1968 to that in 1974?
Your answer should be very brief. 0.67. What is the ratio of the Electricity production(% of total) in Coal sources in 1969 to that in 1970?
Ensure brevity in your answer.  1.04. What is the ratio of the Electricity production(% of total) of Natural gas sources in 1969 to that in 1970?
Your answer should be compact. 0.78. What is the ratio of the Electricity production(% of total) of Oil sources in 1969 to that in 1970?
Provide a short and direct response. 0.9. What is the ratio of the Electricity production(% of total) of Coal sources in 1969 to that in 1971?
Ensure brevity in your answer.  0.96. What is the ratio of the Electricity production(% of total) of Natural gas sources in 1969 to that in 1971?
Your response must be concise. 0.49. What is the ratio of the Electricity production(% of total) in Oil sources in 1969 to that in 1971?
Make the answer very short. 0.81. What is the ratio of the Electricity production(% of total) in Coal sources in 1969 to that in 1972?
Make the answer very short. 1.05. What is the ratio of the Electricity production(% of total) in Natural gas sources in 1969 to that in 1972?
Offer a terse response. 0.43. What is the ratio of the Electricity production(% of total) in Oil sources in 1969 to that in 1972?
Provide a succinct answer. 0.74. What is the ratio of the Electricity production(% of total) in Coal sources in 1969 to that in 1973?
Your answer should be compact. 1.05. What is the ratio of the Electricity production(% of total) of Natural gas sources in 1969 to that in 1973?
Provide a short and direct response. 0.39. What is the ratio of the Electricity production(% of total) of Oil sources in 1969 to that in 1973?
Offer a terse response. 0.72. What is the ratio of the Electricity production(% of total) of Coal sources in 1969 to that in 1974?
Provide a short and direct response. 1.1. What is the ratio of the Electricity production(% of total) of Natural gas sources in 1969 to that in 1974?
Offer a very short reply. 0.33. What is the ratio of the Electricity production(% of total) of Oil sources in 1969 to that in 1974?
Offer a very short reply. 0.76. What is the ratio of the Electricity production(% of total) of Coal sources in 1970 to that in 1971?
Make the answer very short. 0.93. What is the ratio of the Electricity production(% of total) in Natural gas sources in 1970 to that in 1971?
Your response must be concise. 0.63. What is the ratio of the Electricity production(% of total) in Oil sources in 1970 to that in 1971?
Offer a terse response. 0.9. What is the ratio of the Electricity production(% of total) in Coal sources in 1970 to that in 1972?
Offer a terse response. 1.01. What is the ratio of the Electricity production(% of total) of Natural gas sources in 1970 to that in 1972?
Provide a short and direct response. 0.54. What is the ratio of the Electricity production(% of total) in Oil sources in 1970 to that in 1972?
Give a very brief answer. 0.83. What is the ratio of the Electricity production(% of total) of Coal sources in 1970 to that in 1973?
Your response must be concise. 1.01. What is the ratio of the Electricity production(% of total) in Natural gas sources in 1970 to that in 1973?
Make the answer very short. 0.5. What is the ratio of the Electricity production(% of total) in Oil sources in 1970 to that in 1973?
Offer a very short reply. 0.81. What is the ratio of the Electricity production(% of total) in Coal sources in 1970 to that in 1974?
Your answer should be very brief. 1.06. What is the ratio of the Electricity production(% of total) of Natural gas sources in 1970 to that in 1974?
Offer a very short reply. 0.42. What is the ratio of the Electricity production(% of total) in Oil sources in 1970 to that in 1974?
Your answer should be very brief. 0.85. What is the ratio of the Electricity production(% of total) of Coal sources in 1971 to that in 1972?
Your answer should be very brief. 1.08. What is the ratio of the Electricity production(% of total) in Natural gas sources in 1971 to that in 1972?
Your answer should be very brief. 0.87. What is the ratio of the Electricity production(% of total) in Oil sources in 1971 to that in 1972?
Give a very brief answer. 0.91. What is the ratio of the Electricity production(% of total) in Coal sources in 1971 to that in 1973?
Your answer should be very brief. 1.09. What is the ratio of the Electricity production(% of total) of Natural gas sources in 1971 to that in 1973?
Your answer should be compact. 0.79. What is the ratio of the Electricity production(% of total) of Oil sources in 1971 to that in 1973?
Make the answer very short. 0.89. What is the ratio of the Electricity production(% of total) in Coal sources in 1971 to that in 1974?
Your response must be concise. 1.14. What is the ratio of the Electricity production(% of total) in Natural gas sources in 1971 to that in 1974?
Give a very brief answer. 0.67. What is the ratio of the Electricity production(% of total) in Oil sources in 1971 to that in 1974?
Provide a succinct answer. 0.94. What is the ratio of the Electricity production(% of total) in Coal sources in 1972 to that in 1973?
Give a very brief answer. 1. What is the ratio of the Electricity production(% of total) of Natural gas sources in 1972 to that in 1973?
Your answer should be compact. 0.92. What is the ratio of the Electricity production(% of total) of Oil sources in 1972 to that in 1973?
Your answer should be very brief. 0.98. What is the ratio of the Electricity production(% of total) in Coal sources in 1972 to that in 1974?
Offer a very short reply. 1.05. What is the ratio of the Electricity production(% of total) of Natural gas sources in 1972 to that in 1974?
Provide a succinct answer. 0.77. What is the ratio of the Electricity production(% of total) in Oil sources in 1972 to that in 1974?
Provide a succinct answer. 1.03. What is the ratio of the Electricity production(% of total) in Coal sources in 1973 to that in 1974?
Offer a terse response. 1.05. What is the ratio of the Electricity production(% of total) of Natural gas sources in 1973 to that in 1974?
Your response must be concise. 0.84. What is the ratio of the Electricity production(% of total) of Oil sources in 1973 to that in 1974?
Make the answer very short. 1.05. What is the difference between the highest and the second highest Electricity production(% of total) of Coal sources?
Ensure brevity in your answer.  0.25. What is the difference between the highest and the second highest Electricity production(% of total) of Natural gas sources?
Give a very brief answer. 1.69. What is the difference between the highest and the second highest Electricity production(% of total) of Oil sources?
Make the answer very short. 0.6. What is the difference between the highest and the lowest Electricity production(% of total) of Coal sources?
Give a very brief answer. 5.75. What is the difference between the highest and the lowest Electricity production(% of total) in Natural gas sources?
Provide a succinct answer. 9.03. What is the difference between the highest and the lowest Electricity production(% of total) of Oil sources?
Provide a succinct answer. 10.67. 